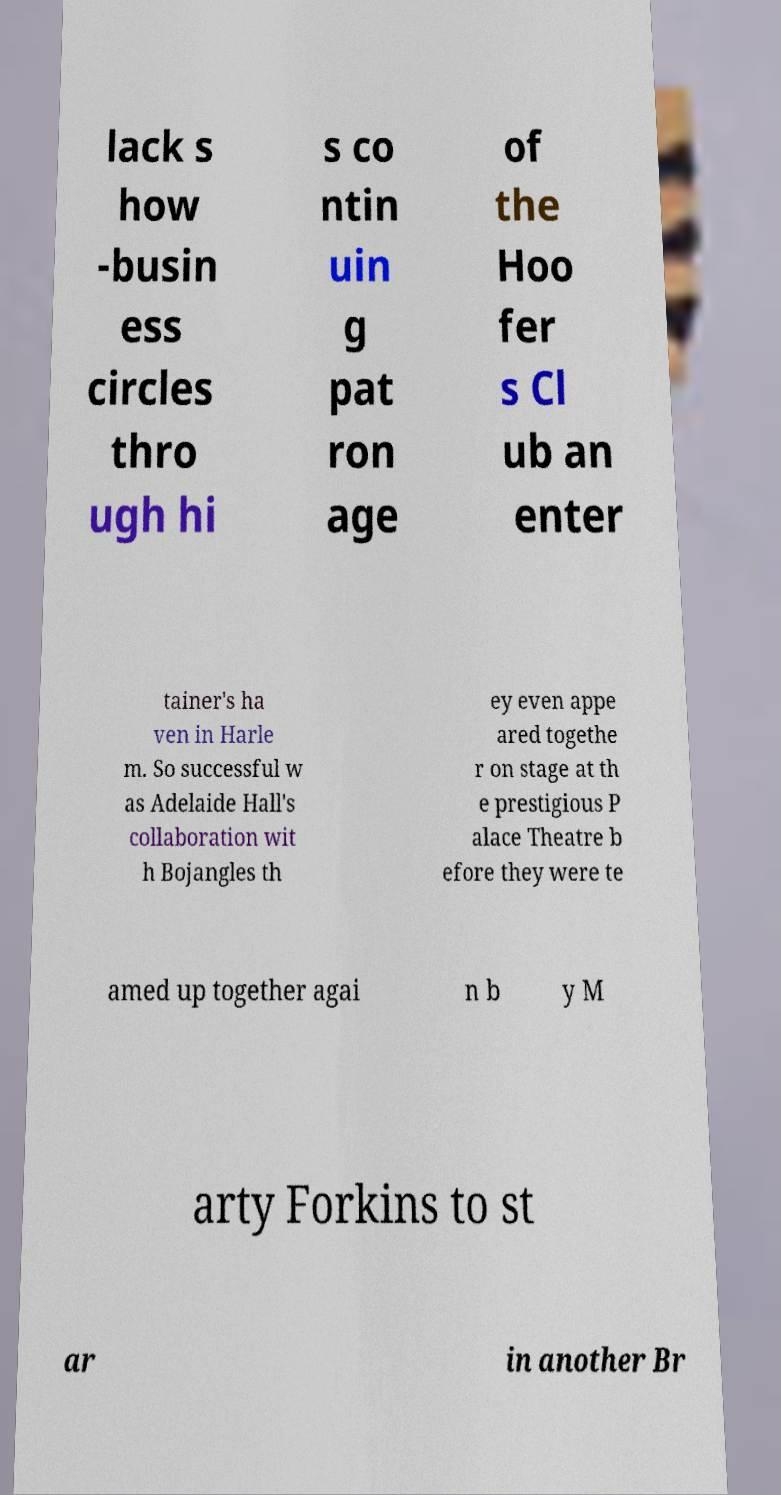Can you accurately transcribe the text from the provided image for me? lack s how -busin ess circles thro ugh hi s co ntin uin g pat ron age of the Hoo fer s Cl ub an enter tainer's ha ven in Harle m. So successful w as Adelaide Hall's collaboration wit h Bojangles th ey even appe ared togethe r on stage at th e prestigious P alace Theatre b efore they were te amed up together agai n b y M arty Forkins to st ar in another Br 